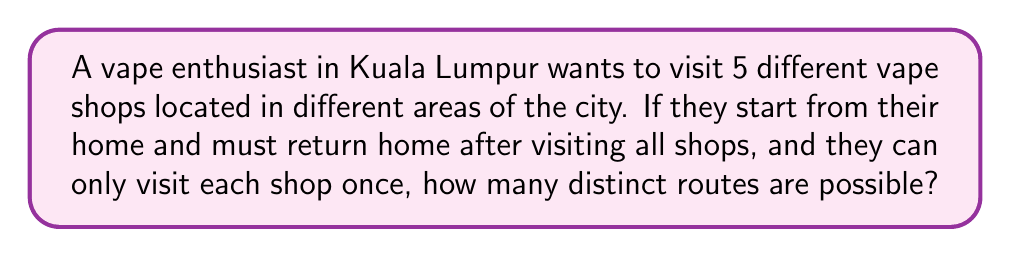Solve this math problem. Let's approach this step-by-step:

1) This problem is a variation of the Traveling Salesman Problem, where we need to find the number of distinct circuits.

2) We start and end at home, so we can consider home as a fixed point. We need to arrange the 5 vape shops in all possible orders.

3) This is a permutation problem. The number of ways to arrange 5 shops is 5! (5 factorial).

4) However, we need to consider that the circuit can be traversed in two directions (clockwise and counterclockwise), which are considered the same route in this context.

5) Therefore, we need to divide our result by 2.

The formula for the number of distinct routes is:

$$ \text{Number of routes} = \frac{5!}{2} $$

6) Let's calculate:
   $$ \frac{5!}{2} = \frac{5 \times 4 \times 3 \times 2 \times 1}{2} = \frac{120}{2} = 60 $$

Thus, there are 60 distinct routes to visit all 5 vape shops and return home.
Answer: 60 